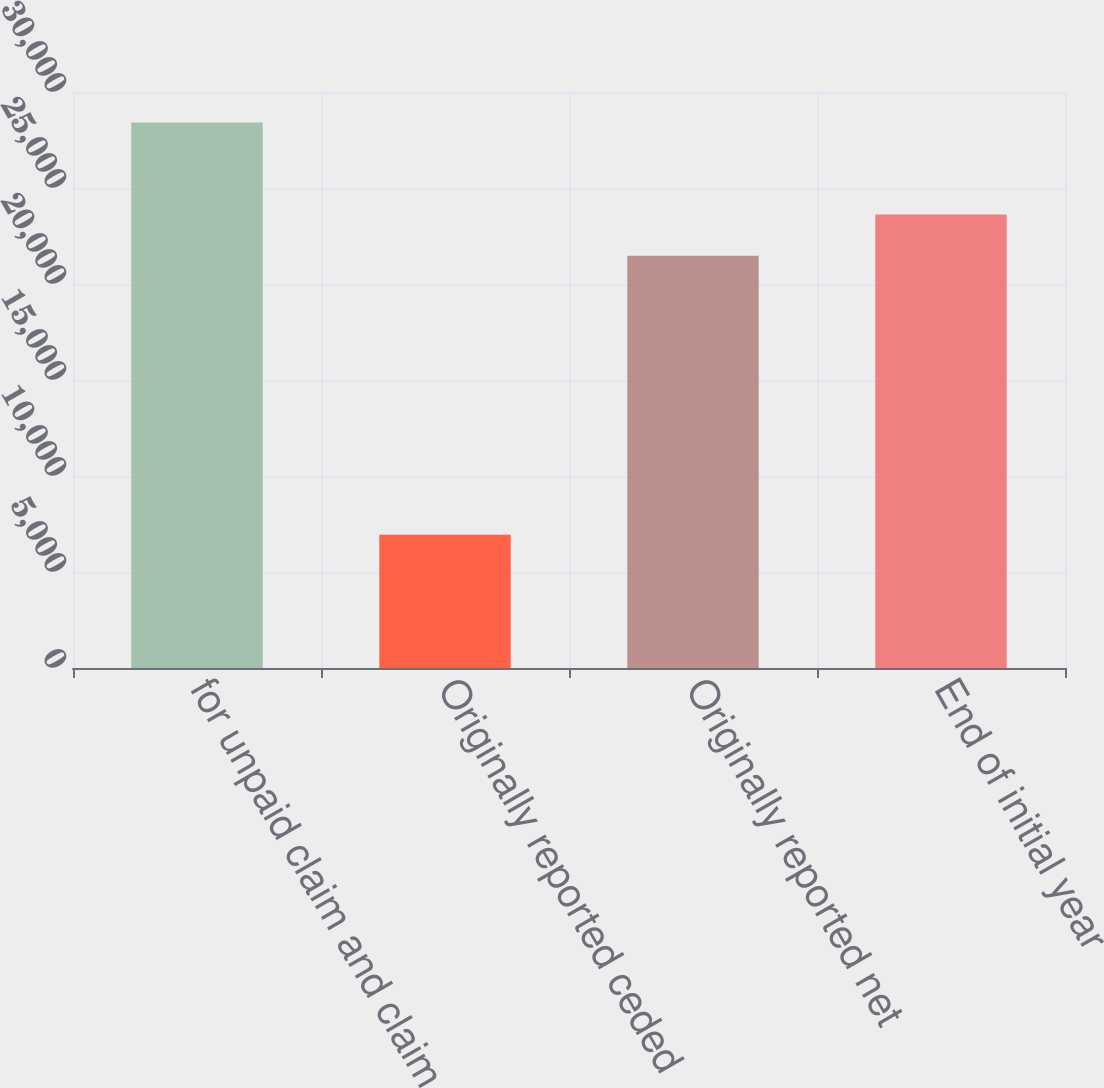Convert chart to OTSL. <chart><loc_0><loc_0><loc_500><loc_500><bar_chart><fcel>for unpaid claim and claim<fcel>Originally reported ceded<fcel>Originally reported net<fcel>End of initial year<nl><fcel>28415<fcel>6945<fcel>21470<fcel>23617<nl></chart> 